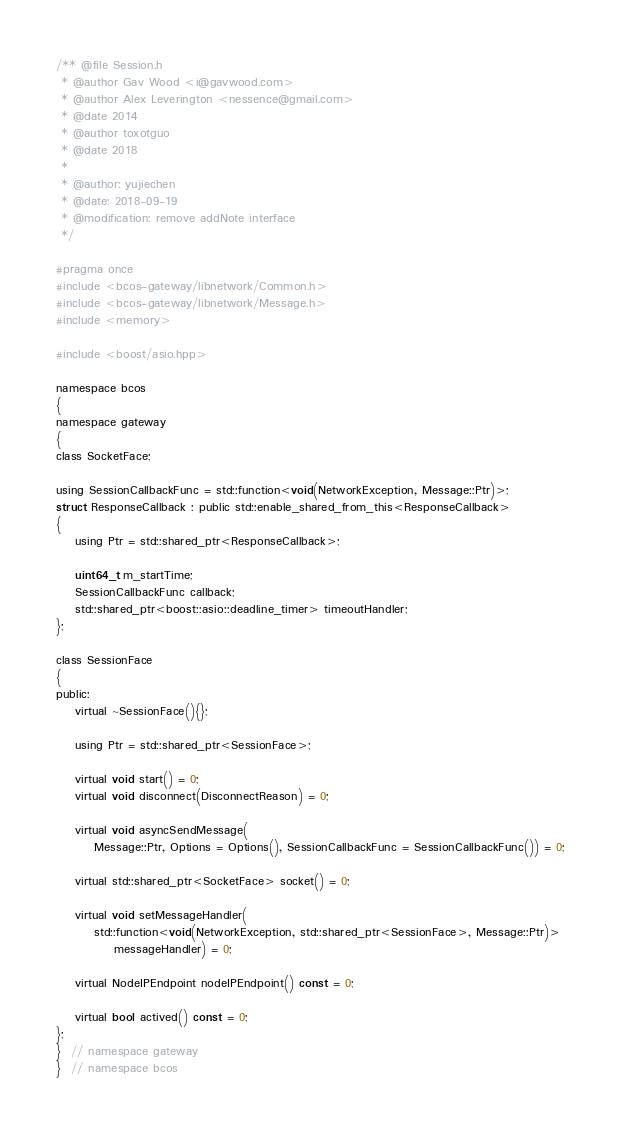Convert code to text. <code><loc_0><loc_0><loc_500><loc_500><_C_>
/** @file Session.h
 * @author Gav Wood <i@gavwood.com>
 * @author Alex Leverington <nessence@gmail.com>
 * @date 2014
 * @author toxotguo
 * @date 2018
 *
 * @author: yujiechen
 * @date: 2018-09-19
 * @modification: remove addNote interface
 */

#pragma once
#include <bcos-gateway/libnetwork/Common.h>
#include <bcos-gateway/libnetwork/Message.h>
#include <memory>

#include <boost/asio.hpp>

namespace bcos
{
namespace gateway
{
class SocketFace;

using SessionCallbackFunc = std::function<void(NetworkException, Message::Ptr)>;
struct ResponseCallback : public std::enable_shared_from_this<ResponseCallback>
{
    using Ptr = std::shared_ptr<ResponseCallback>;

    uint64_t m_startTime;
    SessionCallbackFunc callback;
    std::shared_ptr<boost::asio::deadline_timer> timeoutHandler;
};

class SessionFace
{
public:
    virtual ~SessionFace(){};

    using Ptr = std::shared_ptr<SessionFace>;

    virtual void start() = 0;
    virtual void disconnect(DisconnectReason) = 0;

    virtual void asyncSendMessage(
        Message::Ptr, Options = Options(), SessionCallbackFunc = SessionCallbackFunc()) = 0;

    virtual std::shared_ptr<SocketFace> socket() = 0;

    virtual void setMessageHandler(
        std::function<void(NetworkException, std::shared_ptr<SessionFace>, Message::Ptr)>
            messageHandler) = 0;

    virtual NodeIPEndpoint nodeIPEndpoint() const = 0;

    virtual bool actived() const = 0;
};
}  // namespace gateway
}  // namespace bcos
</code> 